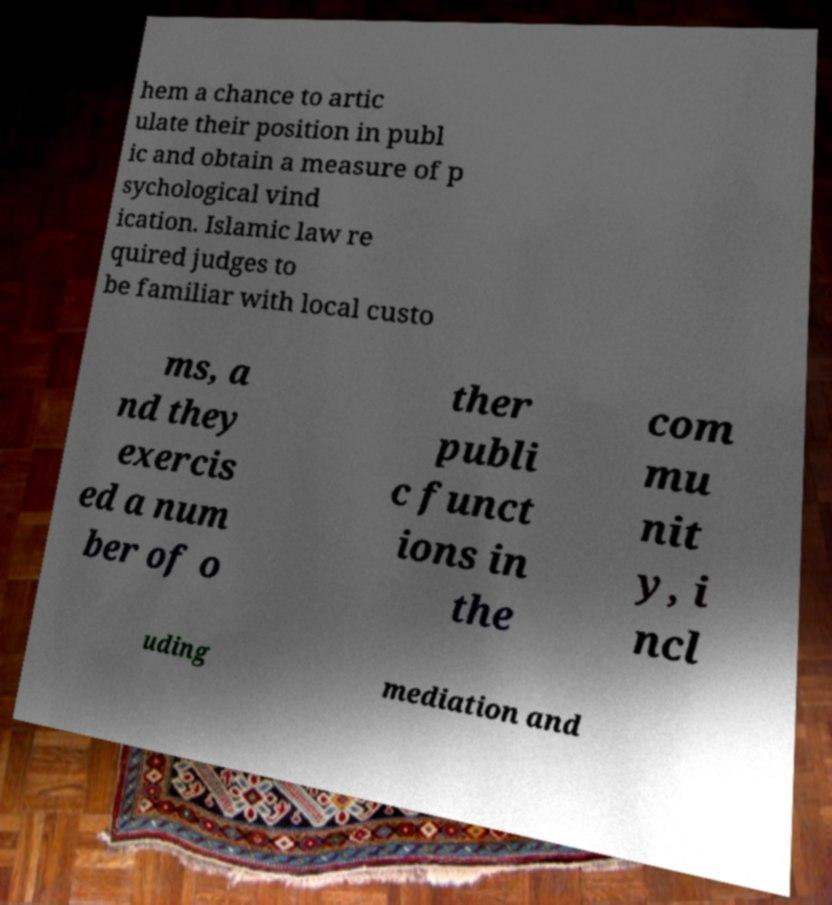Could you extract and type out the text from this image? hem a chance to artic ulate their position in publ ic and obtain a measure of p sychological vind ication. Islamic law re quired judges to be familiar with local custo ms, a nd they exercis ed a num ber of o ther publi c funct ions in the com mu nit y, i ncl uding mediation and 